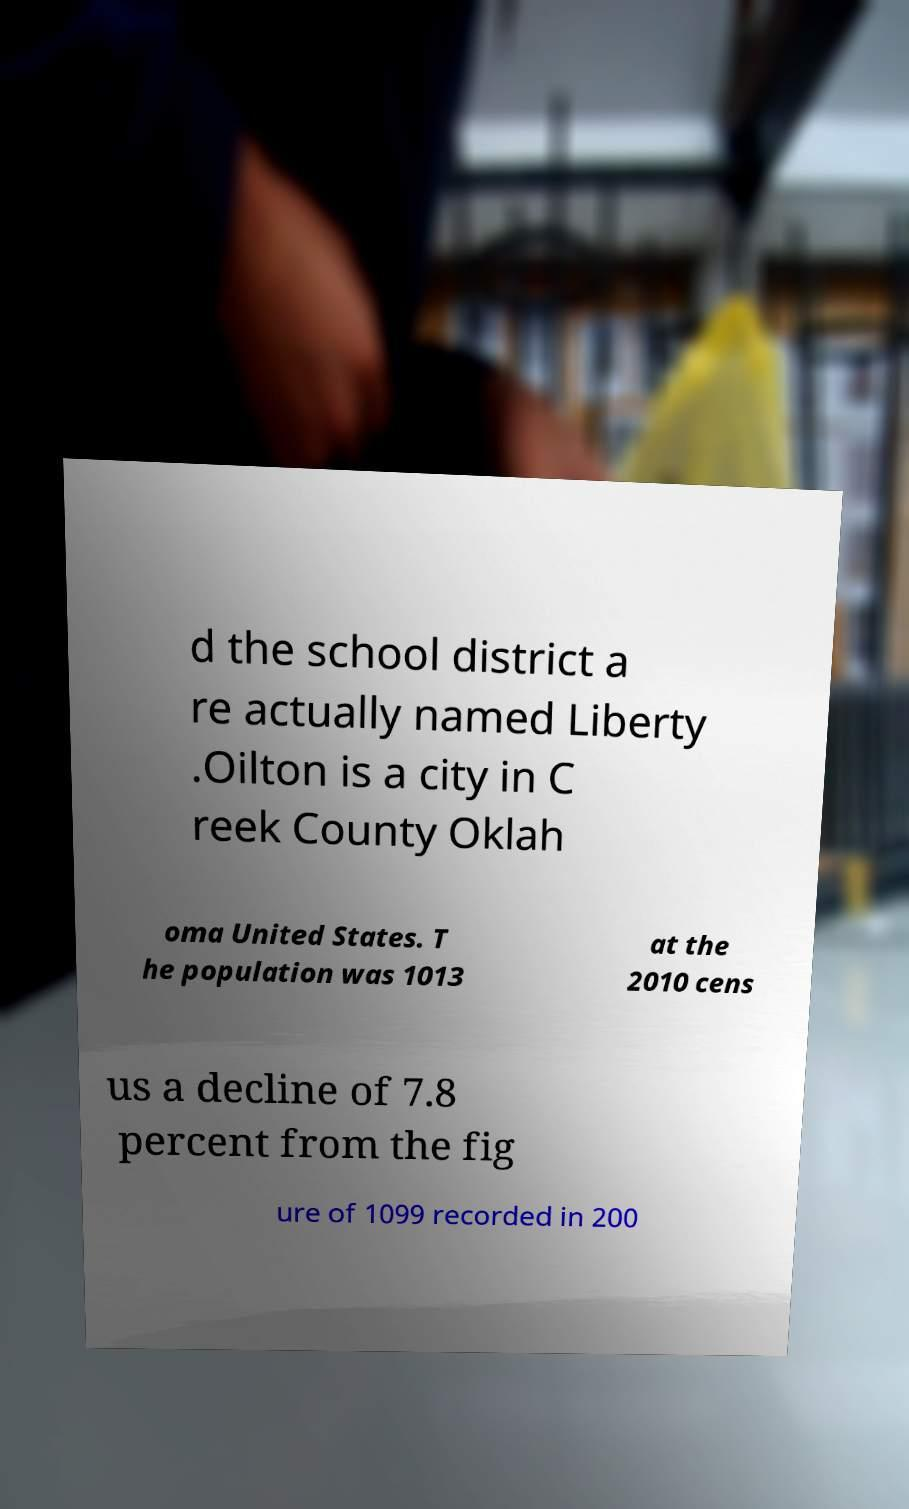Could you assist in decoding the text presented in this image and type it out clearly? d the school district a re actually named Liberty .Oilton is a city in C reek County Oklah oma United States. T he population was 1013 at the 2010 cens us a decline of 7.8 percent from the fig ure of 1099 recorded in 200 